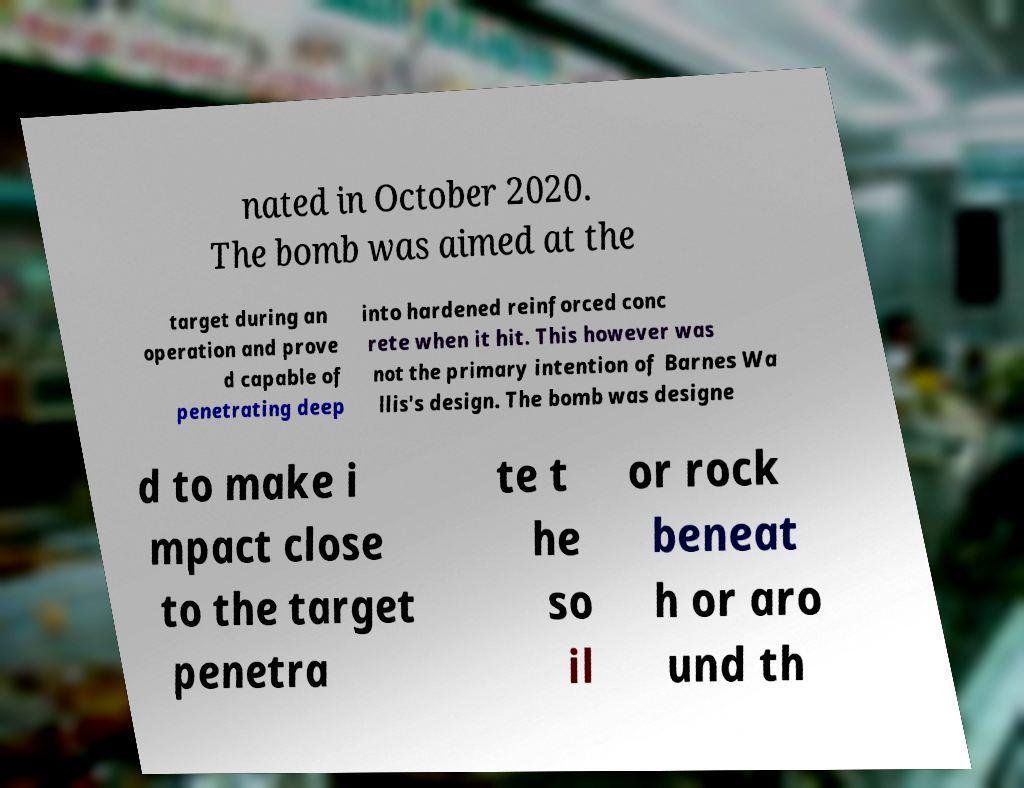Please identify and transcribe the text found in this image. nated in October 2020. The bomb was aimed at the target during an operation and prove d capable of penetrating deep into hardened reinforced conc rete when it hit. This however was not the primary intention of Barnes Wa llis's design. The bomb was designe d to make i mpact close to the target penetra te t he so il or rock beneat h or aro und th 